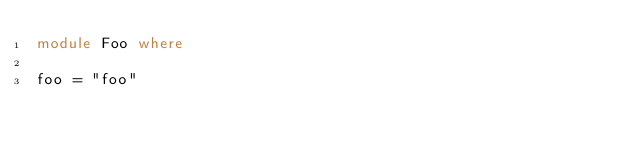Convert code to text. <code><loc_0><loc_0><loc_500><loc_500><_Haskell_>module Foo where

foo = "foo"
</code> 